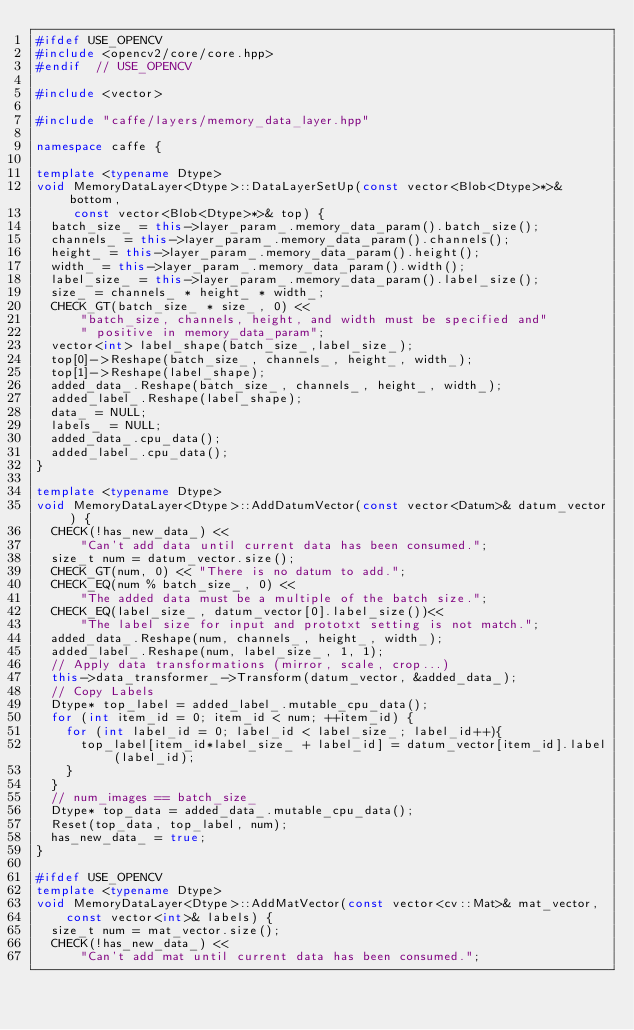<code> <loc_0><loc_0><loc_500><loc_500><_C++_>#ifdef USE_OPENCV
#include <opencv2/core/core.hpp>
#endif  // USE_OPENCV

#include <vector>

#include "caffe/layers/memory_data_layer.hpp"

namespace caffe {

template <typename Dtype>
void MemoryDataLayer<Dtype>::DataLayerSetUp(const vector<Blob<Dtype>*>& bottom,
     const vector<Blob<Dtype>*>& top) {
  batch_size_ = this->layer_param_.memory_data_param().batch_size();
  channels_ = this->layer_param_.memory_data_param().channels();
  height_ = this->layer_param_.memory_data_param().height();
  width_ = this->layer_param_.memory_data_param().width();
  label_size_ = this->layer_param_.memory_data_param().label_size();
  size_ = channels_ * height_ * width_;
  CHECK_GT(batch_size_ * size_, 0) <<
      "batch_size, channels, height, and width must be specified and"
      " positive in memory_data_param";
  vector<int> label_shape(batch_size_,label_size_);
  top[0]->Reshape(batch_size_, channels_, height_, width_);
  top[1]->Reshape(label_shape);
  added_data_.Reshape(batch_size_, channels_, height_, width_);
  added_label_.Reshape(label_shape);
  data_ = NULL;
  labels_ = NULL;
  added_data_.cpu_data();
  added_label_.cpu_data();
}

template <typename Dtype>
void MemoryDataLayer<Dtype>::AddDatumVector(const vector<Datum>& datum_vector) {
  CHECK(!has_new_data_) <<
      "Can't add data until current data has been consumed.";
  size_t num = datum_vector.size();
  CHECK_GT(num, 0) << "There is no datum to add.";
  CHECK_EQ(num % batch_size_, 0) <<
      "The added data must be a multiple of the batch size.";
  CHECK_EQ(label_size_, datum_vector[0].label_size())<<
      "The label size for input and prototxt setting is not match.";
  added_data_.Reshape(num, channels_, height_, width_);
  added_label_.Reshape(num, label_size_, 1, 1);
  // Apply data transformations (mirror, scale, crop...)
  this->data_transformer_->Transform(datum_vector, &added_data_);
  // Copy Labels
  Dtype* top_label = added_label_.mutable_cpu_data();
  for (int item_id = 0; item_id < num; ++item_id) {
    for (int label_id = 0; label_id < label_size_; label_id++){
      top_label[item_id*label_size_ + label_id] = datum_vector[item_id].label(label_id);
    }
  }
  // num_images == batch_size_
  Dtype* top_data = added_data_.mutable_cpu_data();
  Reset(top_data, top_label, num);
  has_new_data_ = true;
}

#ifdef USE_OPENCV
template <typename Dtype>
void MemoryDataLayer<Dtype>::AddMatVector(const vector<cv::Mat>& mat_vector,
    const vector<int>& labels) {
  size_t num = mat_vector.size();
  CHECK(!has_new_data_) <<
      "Can't add mat until current data has been consumed.";</code> 